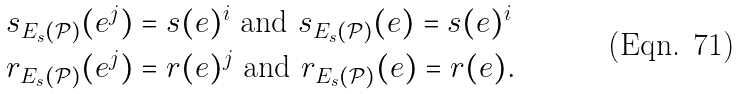Convert formula to latex. <formula><loc_0><loc_0><loc_500><loc_500>s _ { E _ { s } ( \mathcal { P } ) } ( e ^ { j } ) & = s ( e ) ^ { i } \text { and } s _ { E _ { s } ( \mathcal { P } ) } ( e ) = s ( e ) ^ { i } \\ r _ { E _ { s } ( \mathcal { P } ) } ( e ^ { j } ) & = r ( e ) ^ { j } \text { and } r _ { E _ { s } ( \mathcal { P } ) } ( e ) = r ( e ) .</formula> 